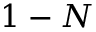Convert formula to latex. <formula><loc_0><loc_0><loc_500><loc_500>1 - N</formula> 